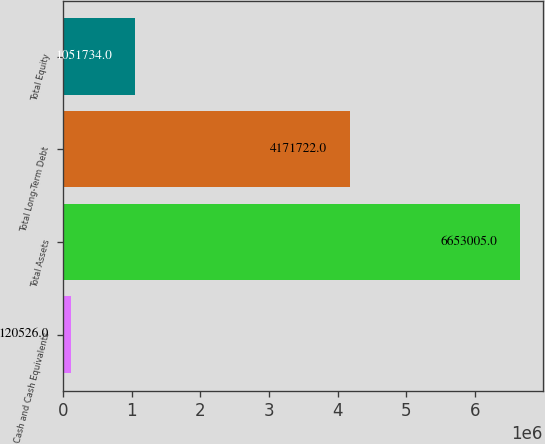Convert chart. <chart><loc_0><loc_0><loc_500><loc_500><bar_chart><fcel>Cash and Cash Equivalents<fcel>Total Assets<fcel>Total Long-Term Debt<fcel>Total Equity<nl><fcel>120526<fcel>6.653e+06<fcel>4.17172e+06<fcel>1.05173e+06<nl></chart> 